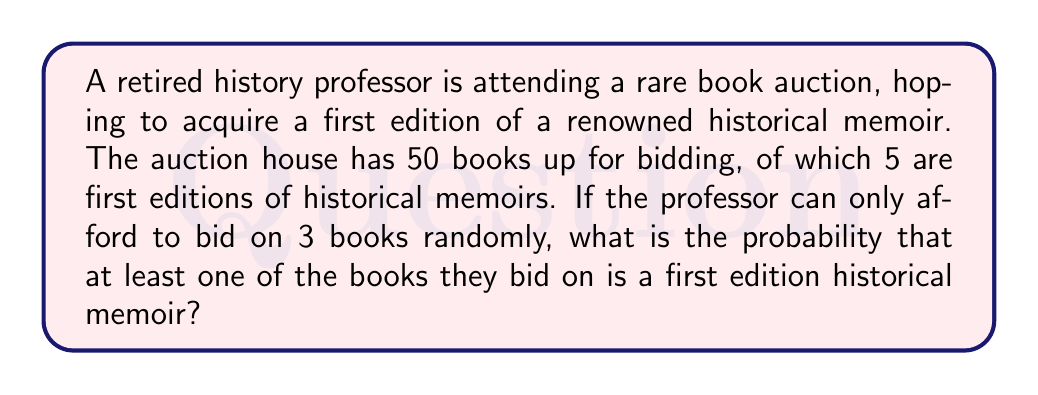Give your solution to this math problem. Let's approach this step-by-step:

1) First, we need to calculate the probability of the opposite event: the probability of not getting any first edition historical memoirs in the 3 bids.

2) There are $\binom{50}{3}$ ways to choose 3 books out of 50.

3) There are 45 books that are not first edition historical memoirs. The number of ways to choose 3 books out of these 45 is $\binom{45}{3}$.

4) The probability of not getting any first edition historical memoirs is:

   $$P(\text{no first editions}) = \frac{\binom{45}{3}}{\binom{50}{3}}$$

5) We can calculate this:
   
   $$\frac{\binom{45}{3}}{\binom{50}{3}} = \frac{45 \cdot 44 \cdot 43 / 6}{50 \cdot 49 \cdot 48 / 6} = \frac{14190}{19600} = 0.7240816327$$

6) The probability of getting at least one first edition historical memoir is the opposite of this:

   $$P(\text{at least one first edition}) = 1 - P(\text{no first editions})$$
   
   $$= 1 - 0.7240816327 = 0.2759183673$$

7) This can be expressed as a percentage: approximately 27.59%
Answer: The probability that the professor will bid on at least one first edition historical memoir is approximately 0.2759 or 27.59%. 